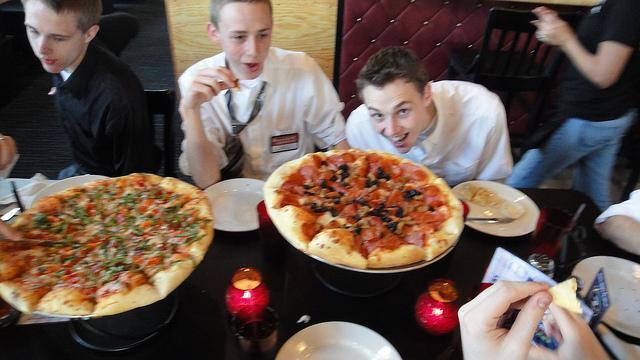What setting is the outfit of the boy sitting in the middle usually found?
Make your selection from the four choices given to correctly answer the question.
Options: Pool, car race, horse race, office. Office. 